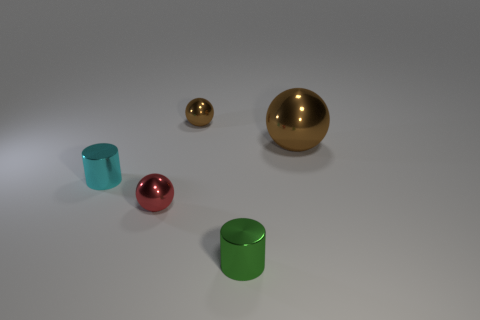Add 2 small red metallic objects. How many objects exist? 7 Subtract all small red balls. How many balls are left? 2 Subtract all purple cylinders. How many brown balls are left? 2 Subtract all red balls. How many balls are left? 2 Subtract all balls. How many objects are left? 2 Subtract all gray metallic objects. Subtract all small cyan cylinders. How many objects are left? 4 Add 2 small red things. How many small red things are left? 3 Add 3 balls. How many balls exist? 6 Subtract 0 blue blocks. How many objects are left? 5 Subtract all red spheres. Subtract all blue blocks. How many spheres are left? 2 